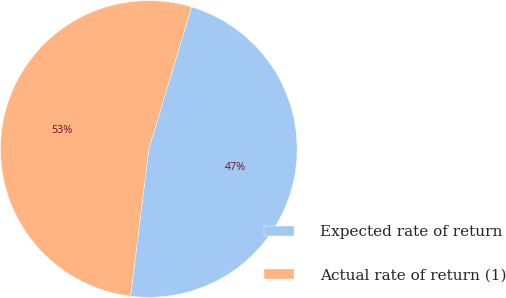Convert chart to OTSL. <chart><loc_0><loc_0><loc_500><loc_500><pie_chart><fcel>Expected rate of return<fcel>Actual rate of return (1)<nl><fcel>47.3%<fcel>52.7%<nl></chart> 